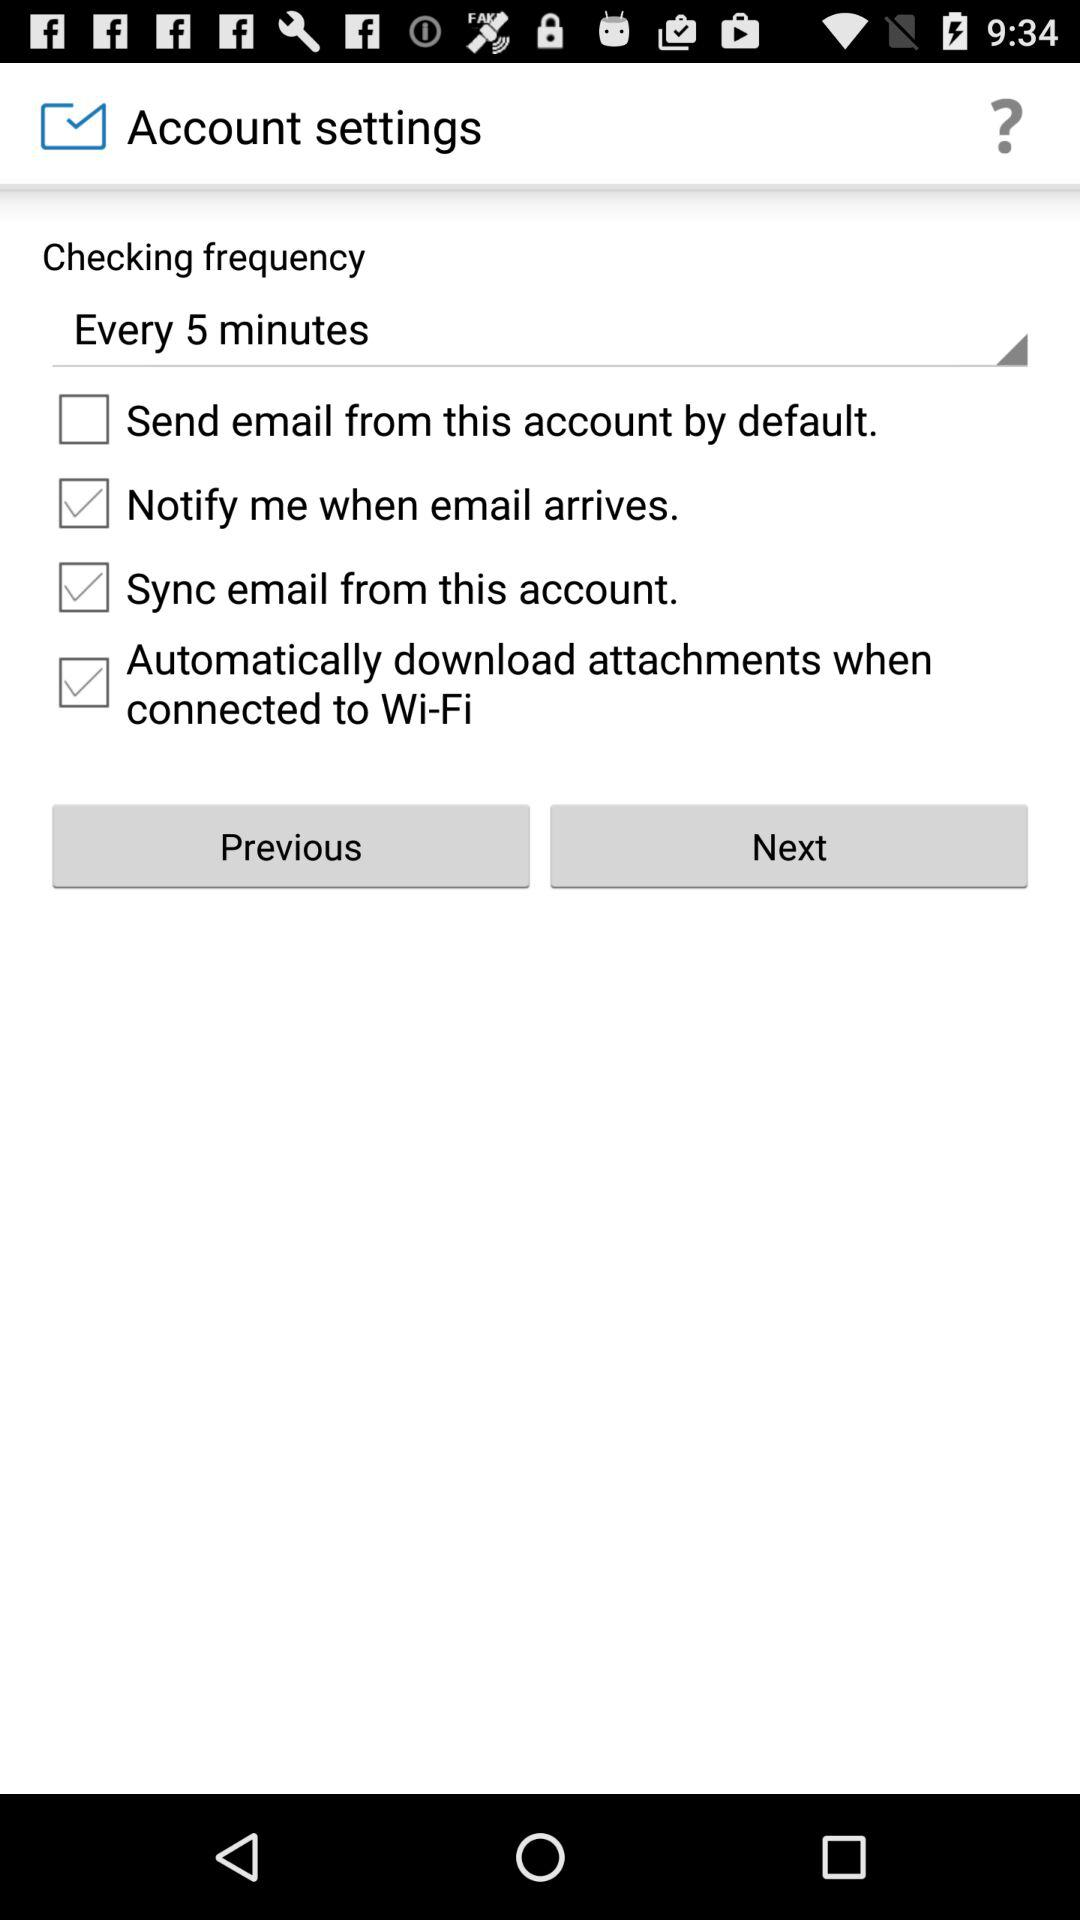What is the status of "Notify me when email arrives"? The status of "Notify me when email arrives" is "on". 